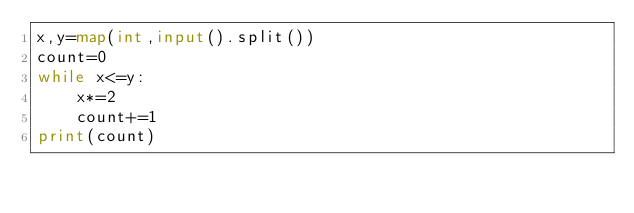Convert code to text. <code><loc_0><loc_0><loc_500><loc_500><_Python_>x,y=map(int,input().split())
count=0
while x<=y:
    x*=2
    count+=1
print(count)</code> 